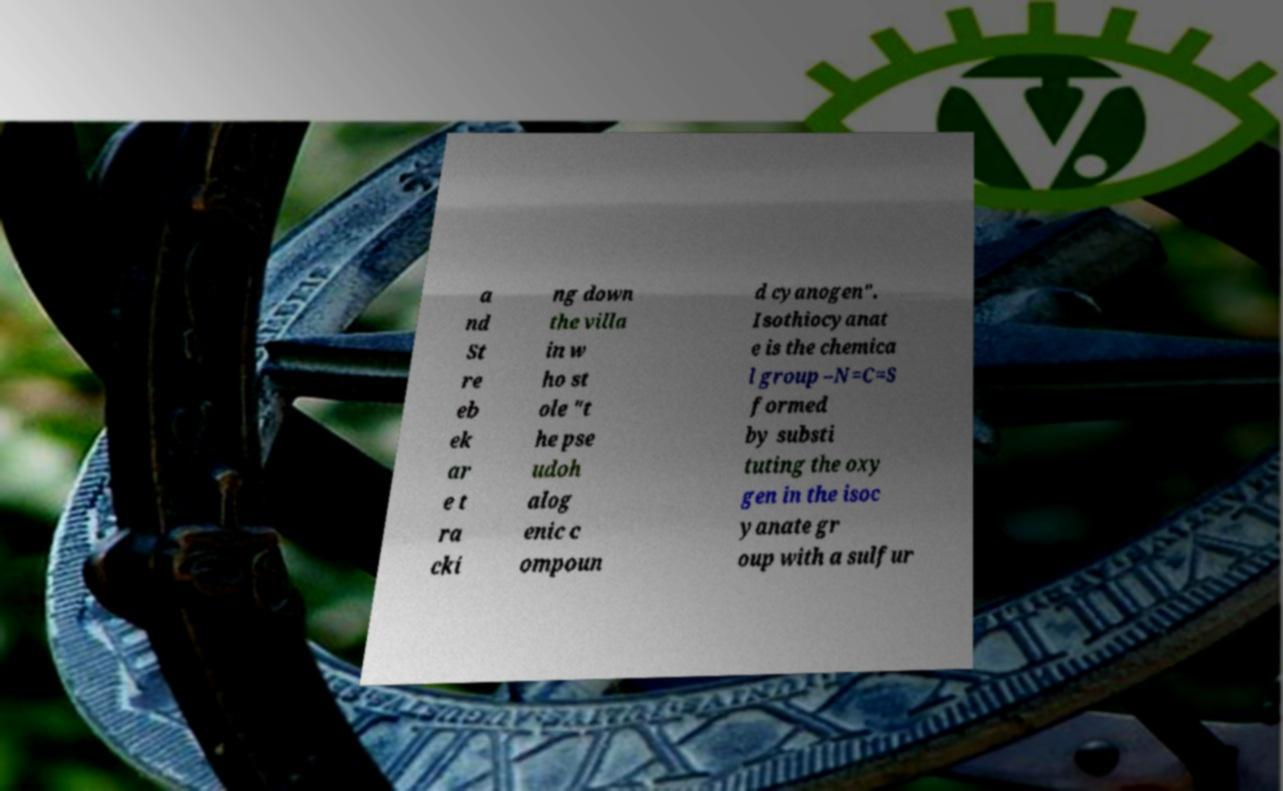What messages or text are displayed in this image? I need them in a readable, typed format. a nd St re eb ek ar e t ra cki ng down the villa in w ho st ole "t he pse udoh alog enic c ompoun d cyanogen". Isothiocyanat e is the chemica l group –N=C=S formed by substi tuting the oxy gen in the isoc yanate gr oup with a sulfur 